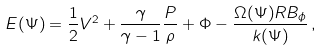Convert formula to latex. <formula><loc_0><loc_0><loc_500><loc_500>E ( \Psi ) = \frac { 1 } { 2 } V ^ { 2 } + \frac { \gamma } { \gamma - 1 } \frac { P } { \rho } + \Phi - \frac { \Omega ( \Psi ) R B _ { \phi } } { k ( \Psi ) } \, ,</formula> 